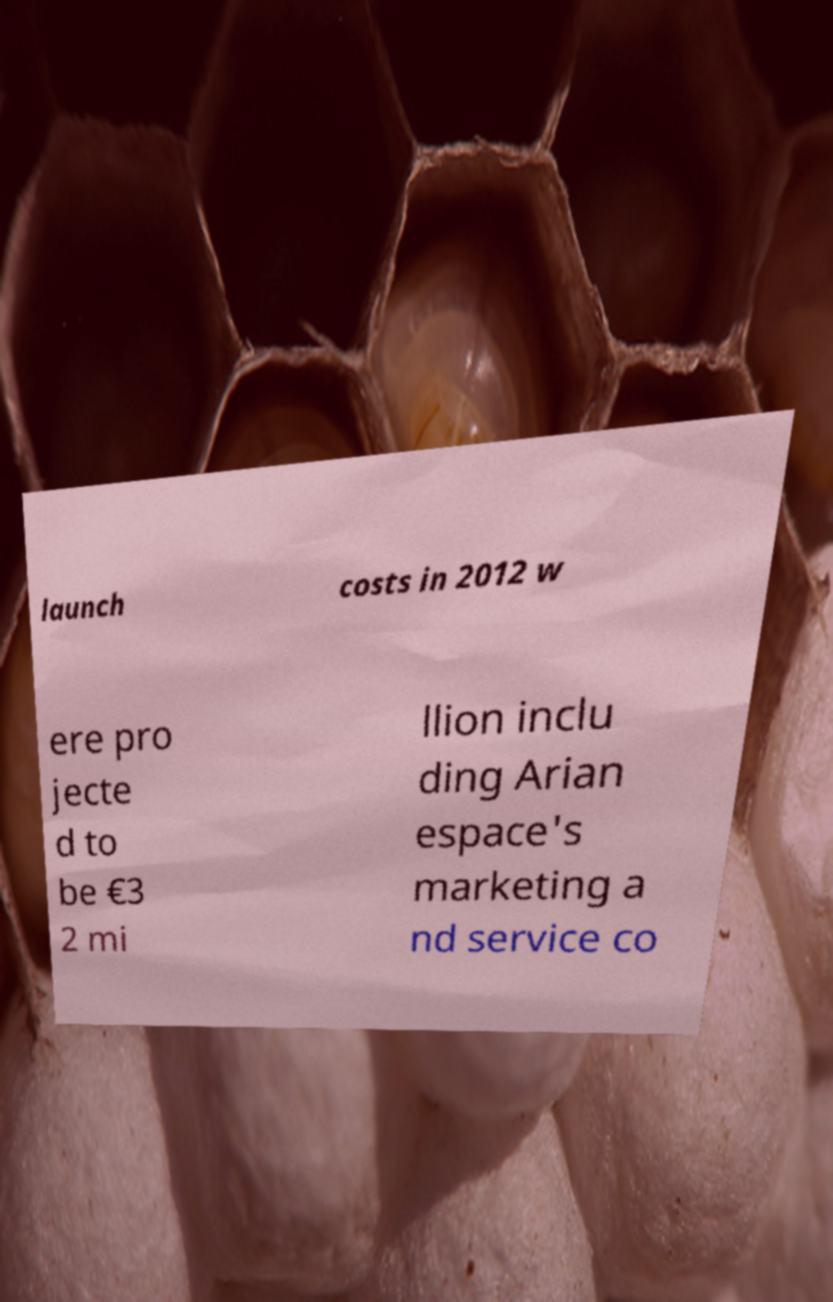Could you assist in decoding the text presented in this image and type it out clearly? launch costs in 2012 w ere pro jecte d to be €3 2 mi llion inclu ding Arian espace's marketing a nd service co 